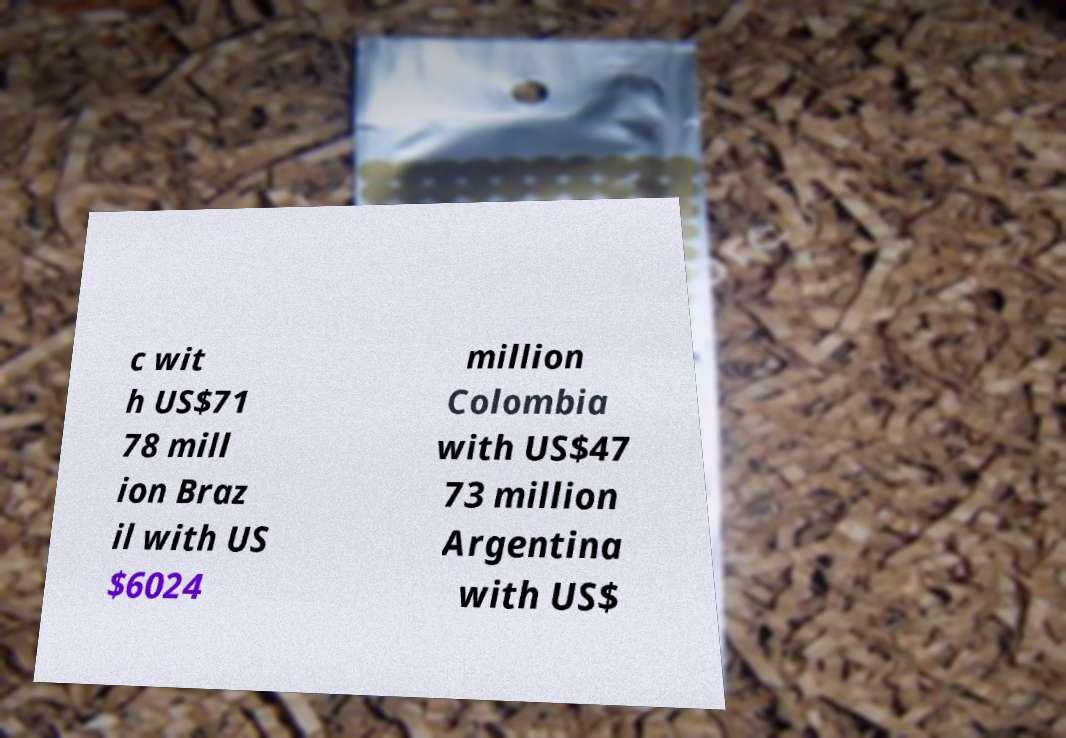There's text embedded in this image that I need extracted. Can you transcribe it verbatim? c wit h US$71 78 mill ion Braz il with US $6024 million Colombia with US$47 73 million Argentina with US$ 